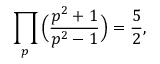Convert formula to latex. <formula><loc_0><loc_0><loc_500><loc_500>\prod _ { p } { \left ( } { \frac { p ^ { 2 } + 1 } { p ^ { 2 } - 1 } } { \right ) } = { \frac { 5 } { 2 } } ,</formula> 